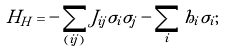Convert formula to latex. <formula><loc_0><loc_0><loc_500><loc_500>H _ { H } = - \sum _ { ( i j ) } J _ { i j } \sigma _ { i } \sigma _ { j } - \sum _ { i } h _ { i } \sigma _ { i } ;</formula> 